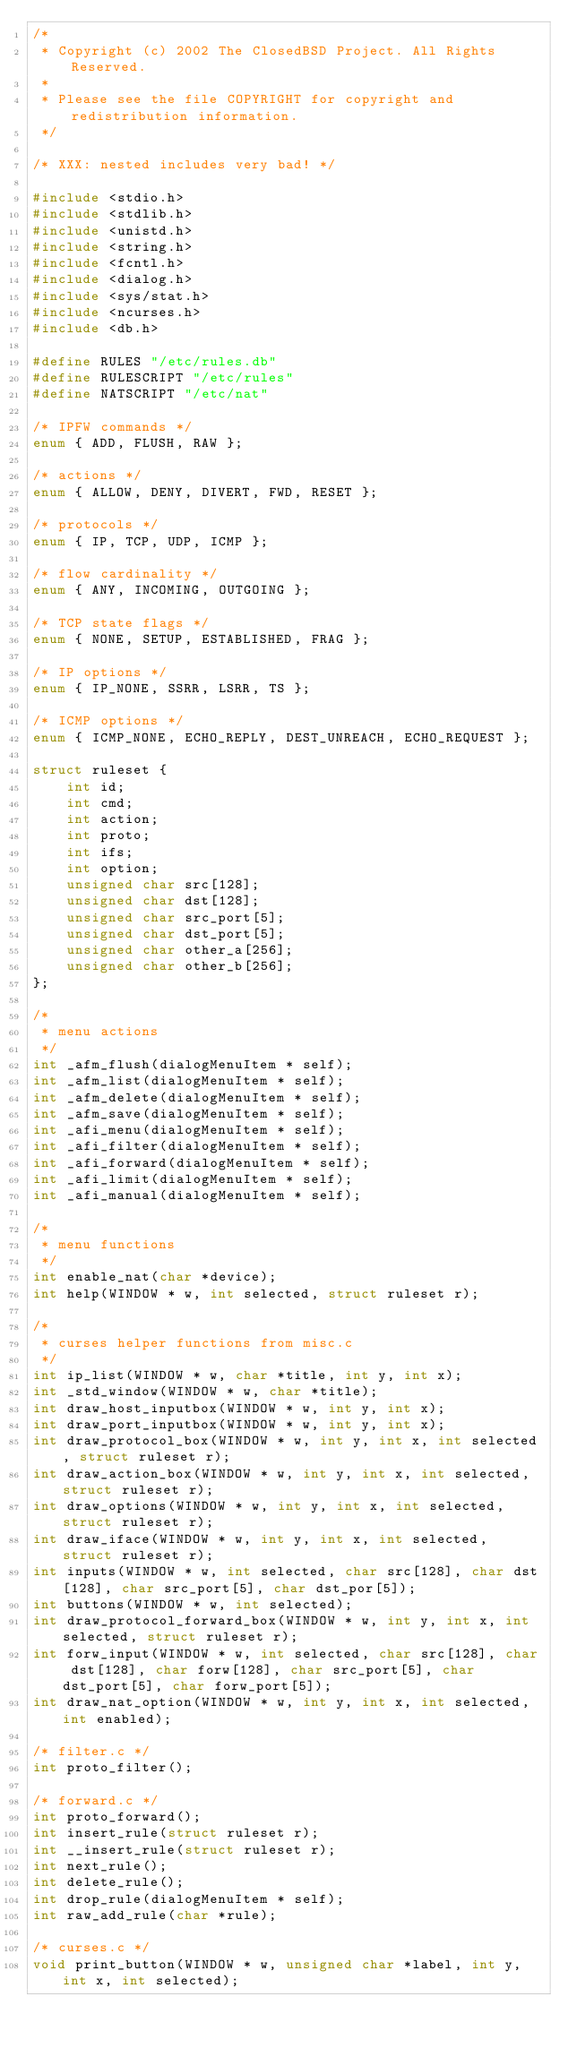<code> <loc_0><loc_0><loc_500><loc_500><_C_>/*
 * Copyright (c) 2002 The ClosedBSD Project. All Rights Reserved.
 *
 * Please see the file COPYRIGHT for copyright and redistribution information.
 */

/* XXX: nested includes very bad! */

#include <stdio.h>
#include <stdlib.h>
#include <unistd.h>
#include <string.h>
#include <fcntl.h>
#include <dialog.h>
#include <sys/stat.h>
#include <ncurses.h>
#include <db.h>

#define RULES "/etc/rules.db"
#define RULESCRIPT "/etc/rules"
#define NATSCRIPT "/etc/nat"

/* IPFW commands */
enum { ADD, FLUSH, RAW };

/* actions */
enum { ALLOW, DENY, DIVERT, FWD, RESET };

/* protocols */
enum { IP, TCP, UDP, ICMP };

/* flow cardinality */
enum { ANY, INCOMING, OUTGOING };

/* TCP state flags */
enum { NONE, SETUP, ESTABLISHED, FRAG };

/* IP options */
enum { IP_NONE, SSRR, LSRR, TS };

/* ICMP options */
enum { ICMP_NONE, ECHO_REPLY, DEST_UNREACH, ECHO_REQUEST };

struct ruleset {
	int id;
	int cmd;
	int action;
	int proto;
	int ifs;
	int option;
	unsigned char src[128];
	unsigned char dst[128];
	unsigned char src_port[5];
	unsigned char dst_port[5];
	unsigned char other_a[256];
	unsigned char other_b[256];
};

/*
 * menu actions
 */
int _afm_flush(dialogMenuItem * self);
int _afm_list(dialogMenuItem * self);
int _afm_delete(dialogMenuItem * self);
int _afm_save(dialogMenuItem * self);
int _afi_menu(dialogMenuItem * self);
int _afi_filter(dialogMenuItem * self);
int _afi_forward(dialogMenuItem * self);
int _afi_limit(dialogMenuItem * self);
int _afi_manual(dialogMenuItem * self);

/*
 * menu functions
 */
int enable_nat(char *device);
int help(WINDOW * w, int selected, struct ruleset r);

/*
 * curses helper functions from misc.c
 */
int ip_list(WINDOW * w, char *title, int y, int x);
int _std_window(WINDOW * w, char *title);
int draw_host_inputbox(WINDOW * w, int y, int x);
int draw_port_inputbox(WINDOW * w, int y, int x);
int draw_protocol_box(WINDOW * w, int y, int x, int selected, struct ruleset r);
int draw_action_box(WINDOW * w, int y, int x, int selected, struct ruleset r);
int draw_options(WINDOW * w, int y, int x, int selected, struct ruleset r);
int draw_iface(WINDOW * w, int y, int x, int selected, struct ruleset r);
int inputs(WINDOW * w, int selected, char src[128], char dst[128], char src_port[5], char dst_por[5]);
int buttons(WINDOW * w, int selected);
int draw_protocol_forward_box(WINDOW * w, int y, int x, int selected, struct ruleset r);
int forw_input(WINDOW * w, int selected, char src[128], char dst[128], char forw[128], char src_port[5], char dst_port[5], char forw_port[5]);
int draw_nat_option(WINDOW * w, int y, int x, int selected, int enabled);

/* filter.c */
int proto_filter();

/* forward.c */
int proto_forward();
int insert_rule(struct ruleset r);
int __insert_rule(struct ruleset r);
int next_rule();
int delete_rule();
int drop_rule(dialogMenuItem * self);
int raw_add_rule(char *rule);

/* curses.c */
void print_button(WINDOW * w, unsigned char *label, int y, int x, int selected);
</code> 